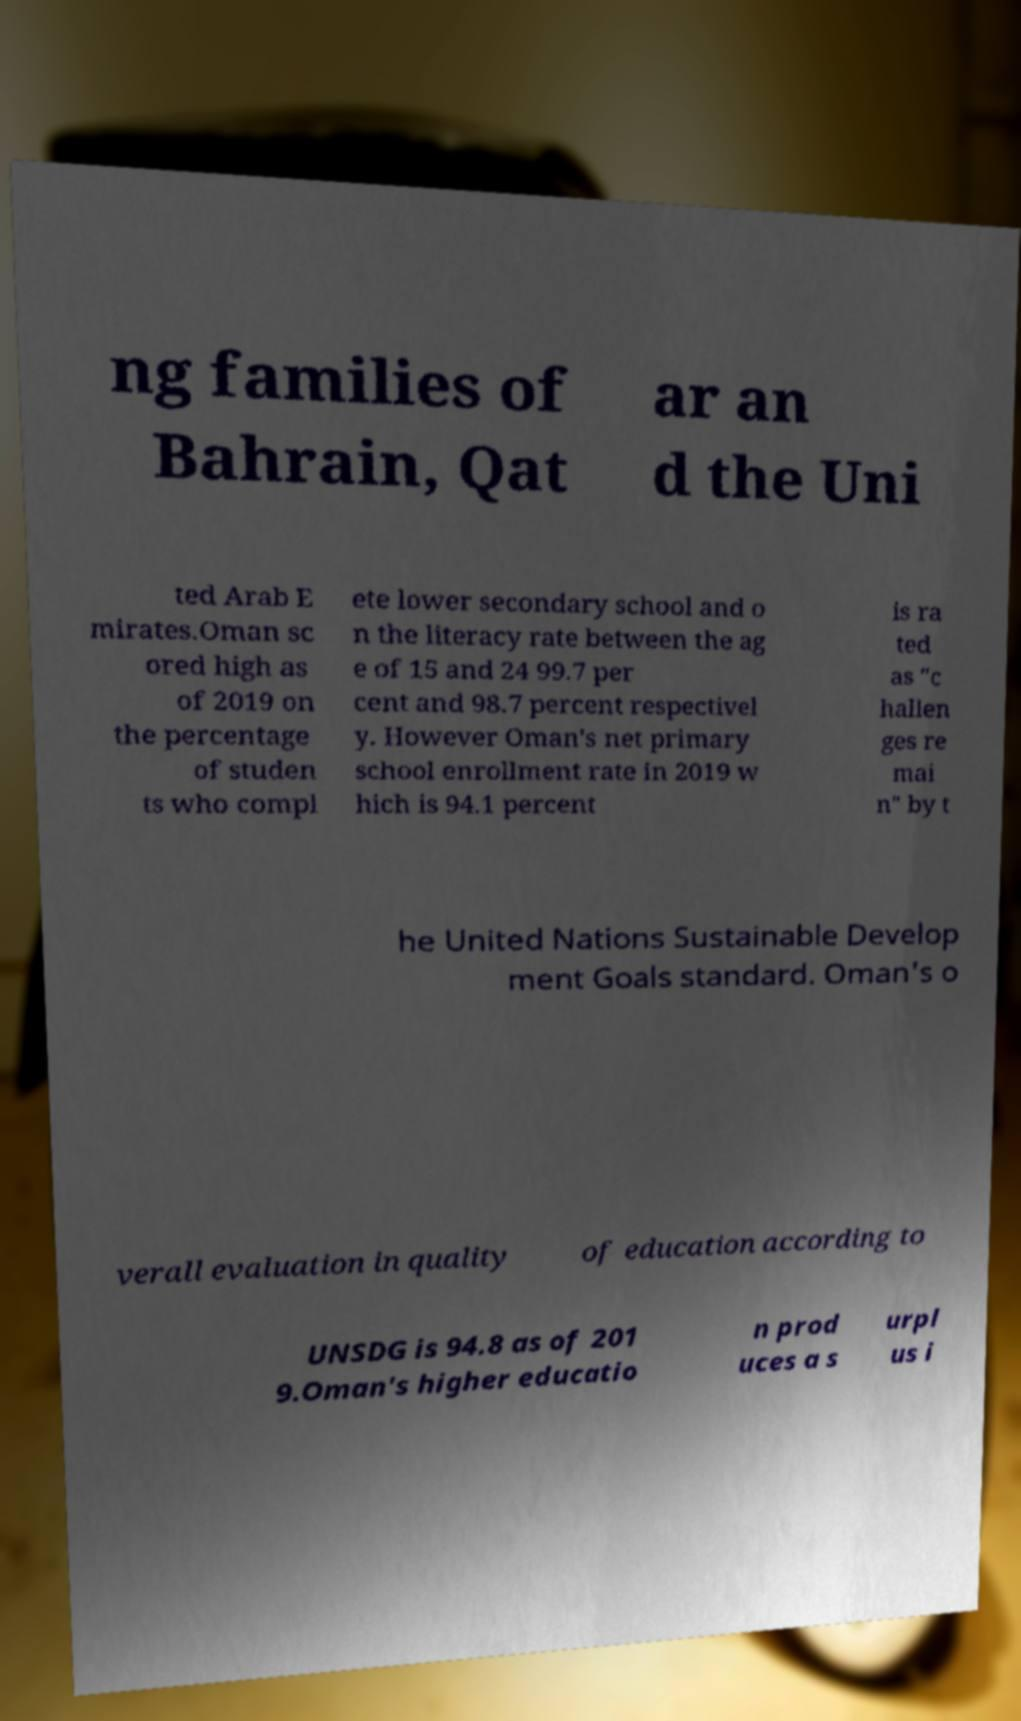Can you read and provide the text displayed in the image?This photo seems to have some interesting text. Can you extract and type it out for me? ng families of Bahrain, Qat ar an d the Uni ted Arab E mirates.Oman sc ored high as of 2019 on the percentage of studen ts who compl ete lower secondary school and o n the literacy rate between the ag e of 15 and 24 99.7 per cent and 98.7 percent respectivel y. However Oman's net primary school enrollment rate in 2019 w hich is 94.1 percent is ra ted as "c hallen ges re mai n" by t he United Nations Sustainable Develop ment Goals standard. Oman's o verall evaluation in quality of education according to UNSDG is 94.8 as of 201 9.Oman's higher educatio n prod uces a s urpl us i 